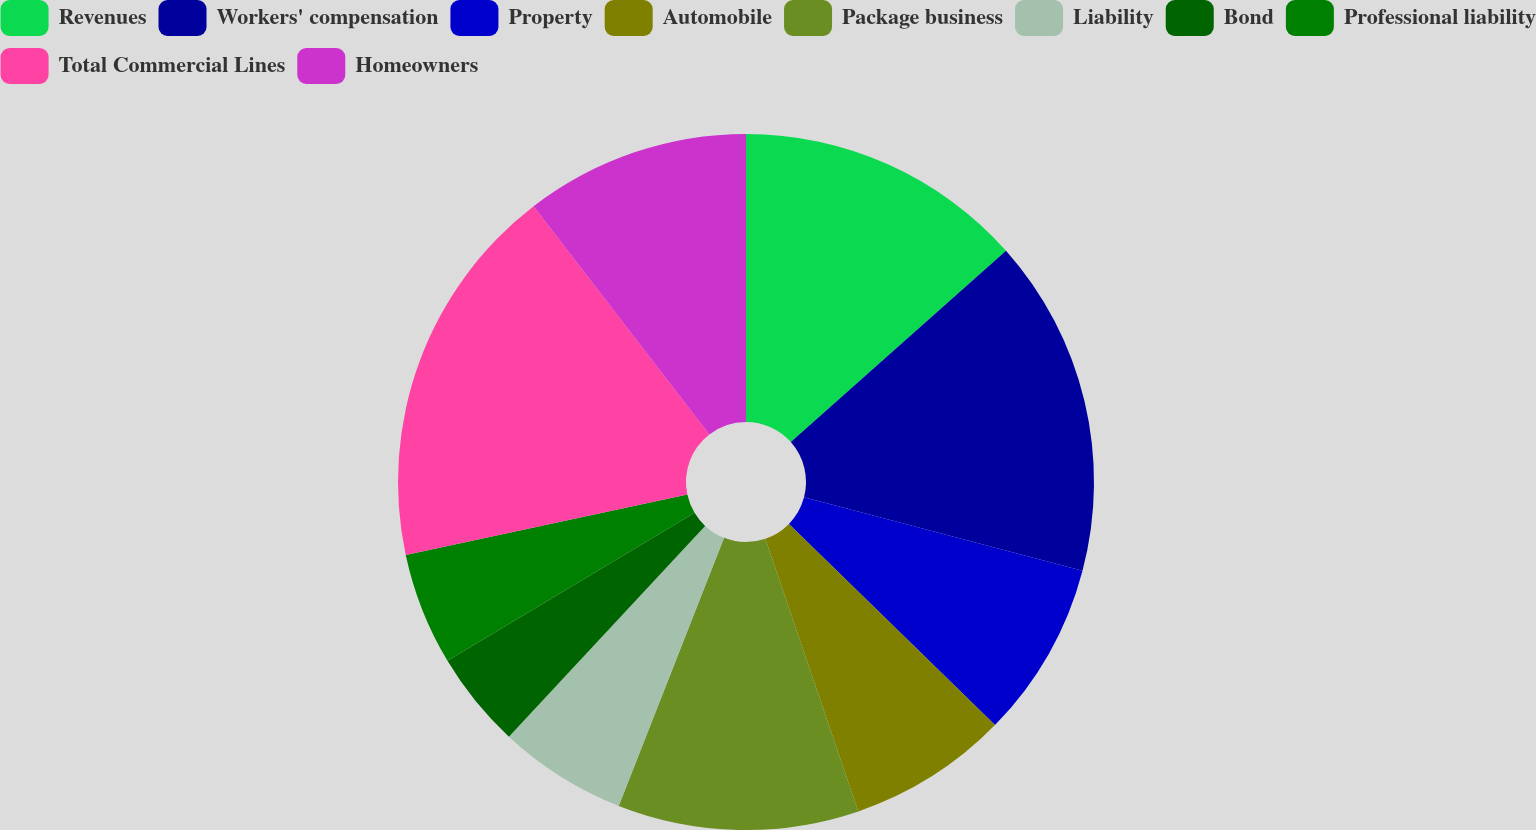Convert chart. <chart><loc_0><loc_0><loc_500><loc_500><pie_chart><fcel>Revenues<fcel>Workers' compensation<fcel>Property<fcel>Automobile<fcel>Package business<fcel>Liability<fcel>Bond<fcel>Professional liability<fcel>Total Commercial Lines<fcel>Homeowners<nl><fcel>13.43%<fcel>15.67%<fcel>8.21%<fcel>7.46%<fcel>11.19%<fcel>5.97%<fcel>4.48%<fcel>5.23%<fcel>17.91%<fcel>10.45%<nl></chart> 